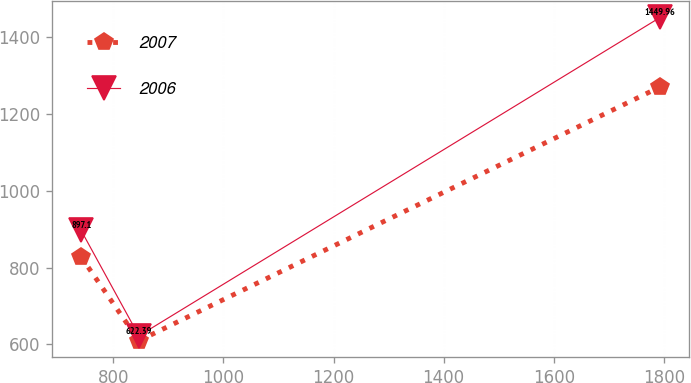<chart> <loc_0><loc_0><loc_500><loc_500><line_chart><ecel><fcel>2007<fcel>2006<nl><fcel>741.3<fcel>828.12<fcel>897.1<nl><fcel>846.49<fcel>609.61<fcel>622.39<nl><fcel>1793.17<fcel>1269.45<fcel>1449.96<nl></chart> 